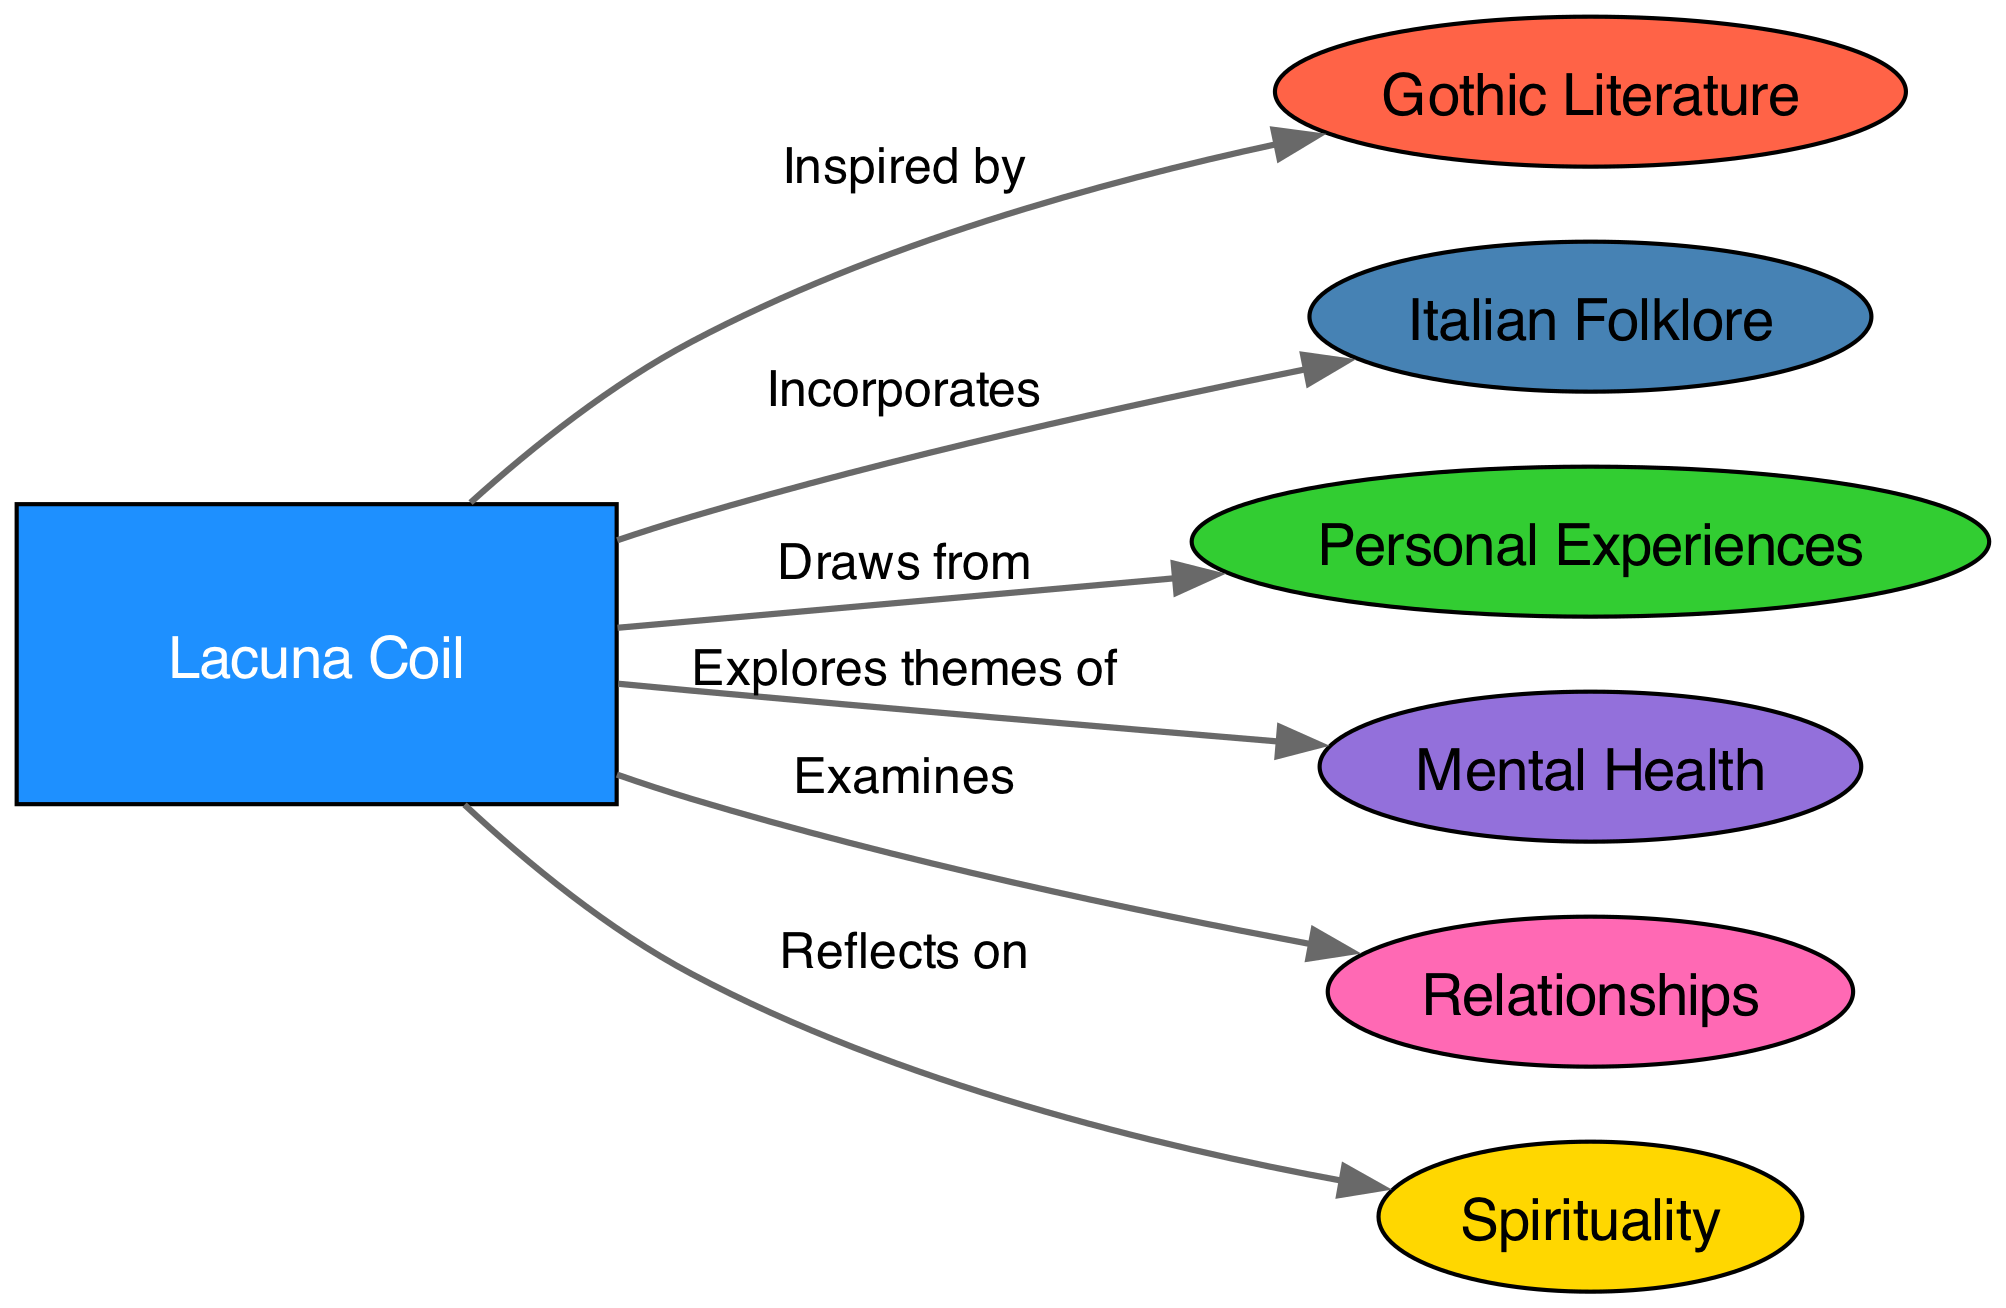What is the central node in the diagram? The central node is "Lacuna Coil" as it is the main entity from which all other nodes and connections radiate.
Answer: Lacuna Coil How many nodes are in the diagram? By counting the nodes listed in the data, there are a total of 7 nodes present in the diagram.
Answer: 7 What type of literature inspires Lacuna Coil? The label "Inspired by" directly connects "Lacuna Coil" to "Gothic Literature," indicating that this is the type of literature that inspires them.
Answer: Gothic Literature Which theme reflects spiritual aspects in Lacuna Coil's discography? The link labeled "Reflects on" connects "Lacuna Coil" to "Spirituality," indicating that spirituality is a theme they explore.
Answer: Spirituality What are the two personal themes explored in Lacuna Coil's music? The connections "Draws from" and "Explores themes of" show that "Personal Experiences" and "Mental Health" are the two explored themes.
Answer: Personal Experiences, Mental Health How does Lacuna Coil incorporate cultural elements into their lyrics? The connection labeled "Incorporates" leads from "Lacuna Coil" to "Italian Folklore," showing that cultural elements from Italian folklore are part of their lyrics.
Answer: Italian Folklore What relationship theme does Lacuna Coil examine? The diagram indicates that the theme "Examines" connects "Lacuna Coil" with "Relationships," indicating this specific theme is presented in their work.
Answer: Relationships Which connections are made directly from "Lacuna Coil"? The edges show that "Lacuna Coil" is connected to Gothic Literature, Italian Folklore, Personal Experiences, Mental Health, Relationships, and Spirituality, presenting a diverse range of influences.
Answer: Gothic Literature, Italian Folklore, Personal Experiences, Mental Health, Relationships, Spirituality Which node indicates a focus on mental health? The relationship labeled "Explores themes of" from "Lacuna Coil" leads to "Mental Health," indicating that this focus is explicitly part of their themes.
Answer: Mental Health 